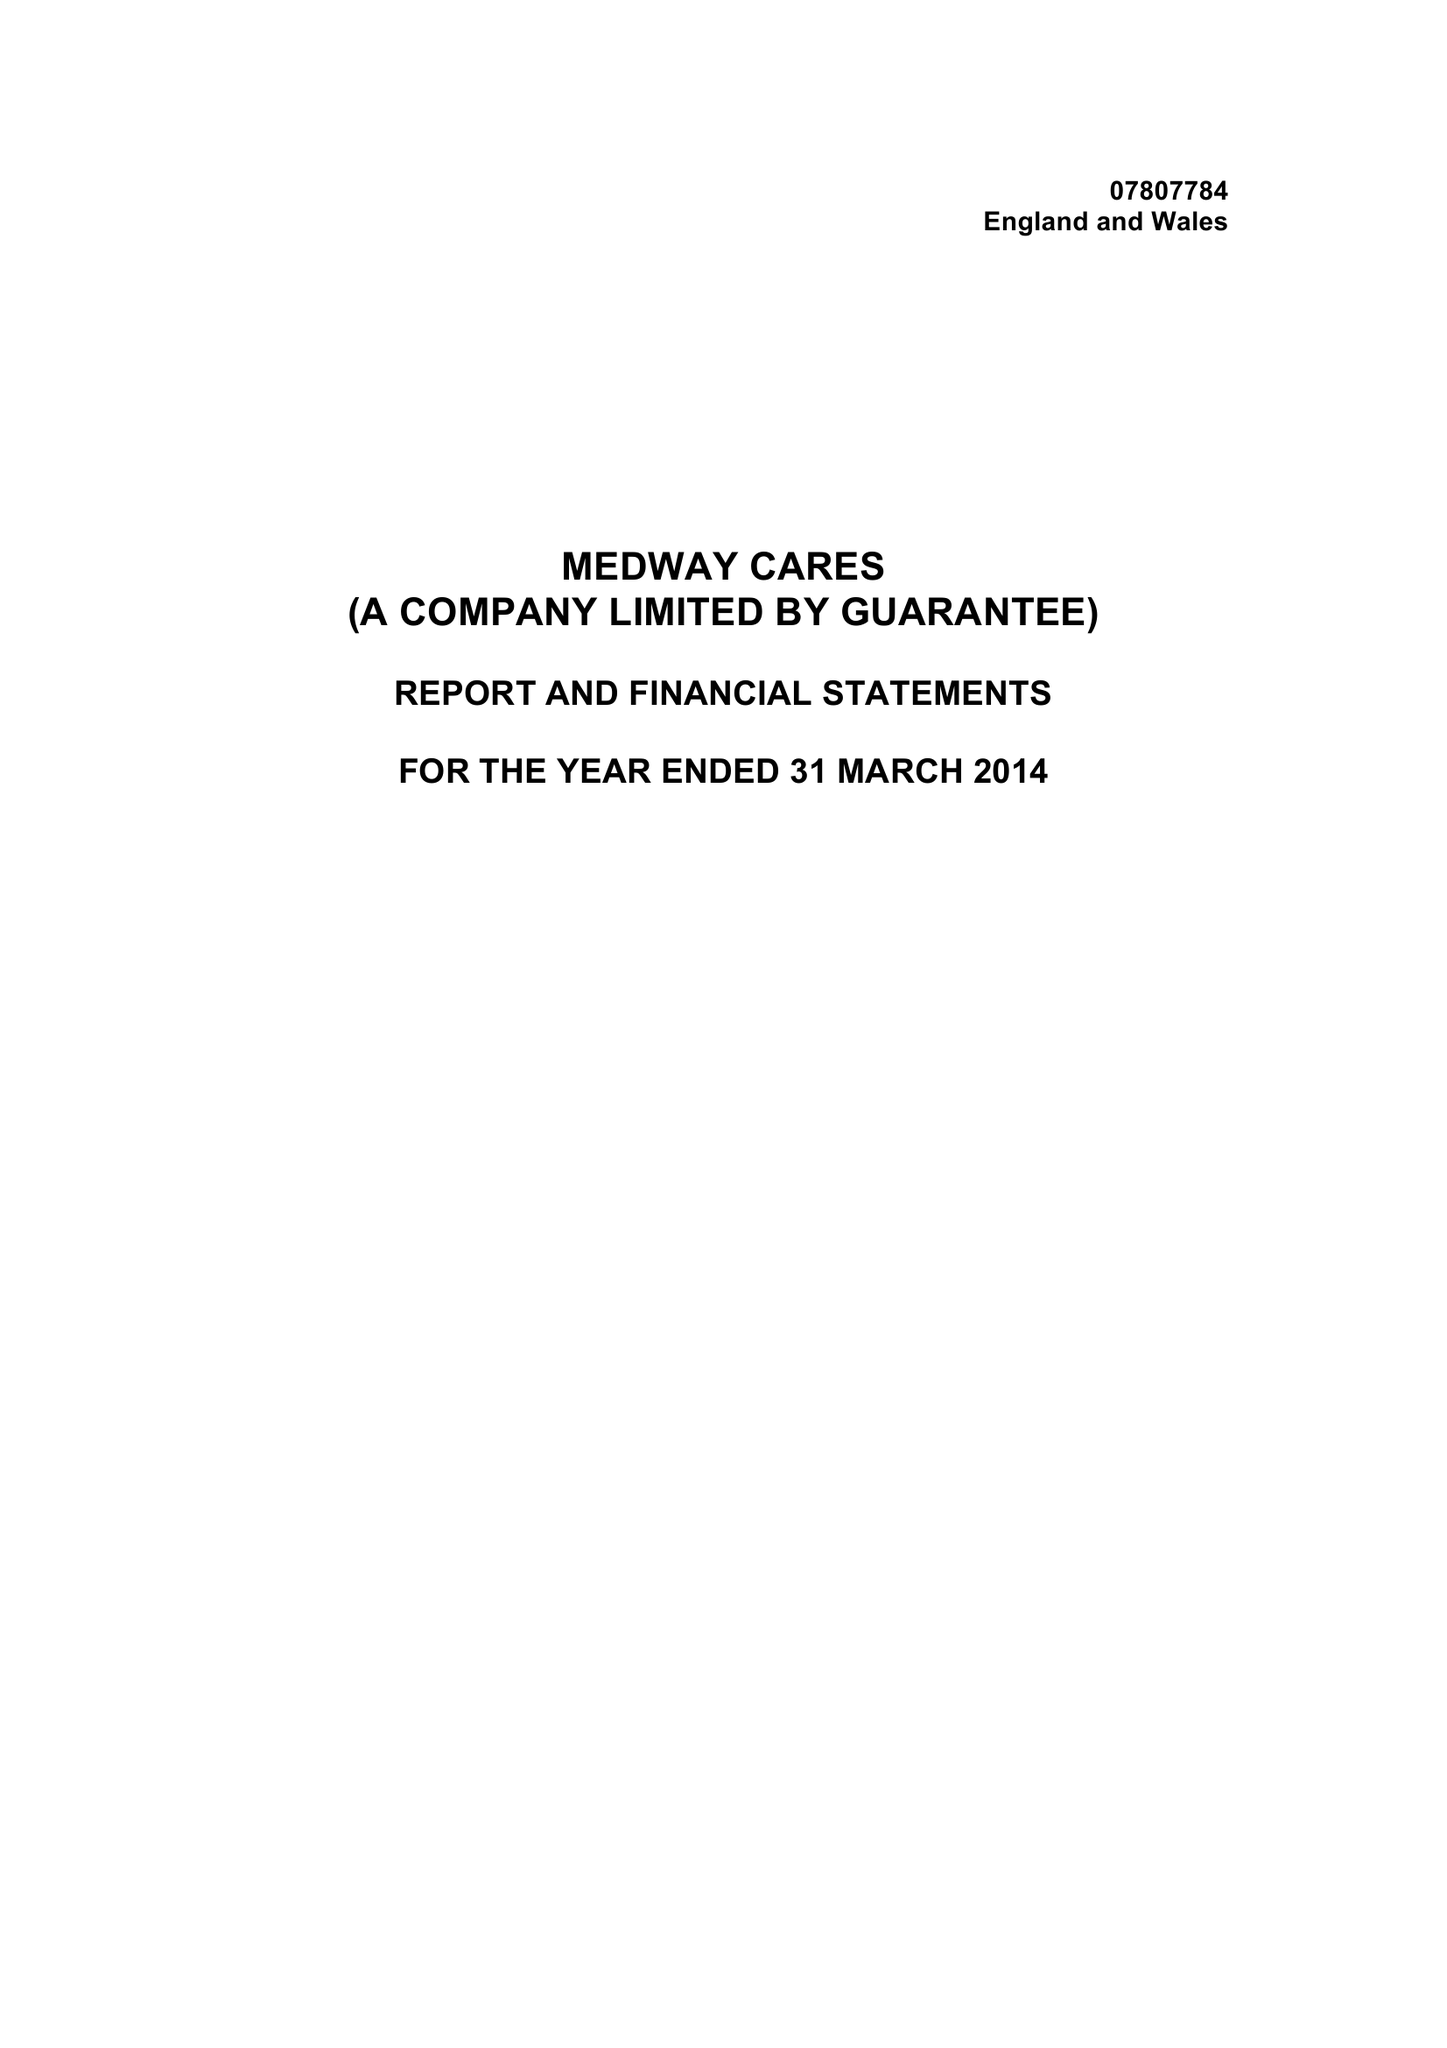What is the value for the charity_name?
Answer the question using a single word or phrase. Medway Cares Ltd. 